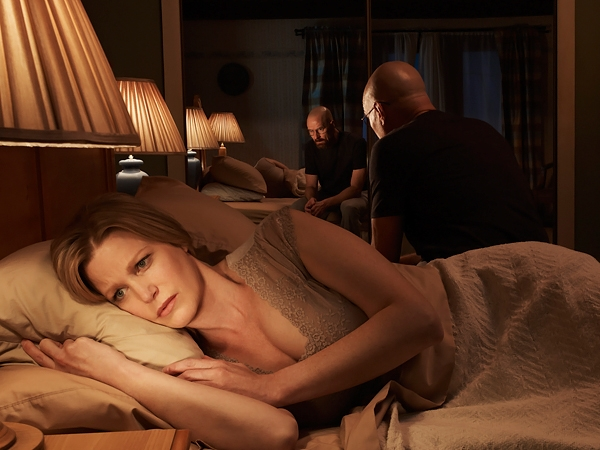What details in the room's decor might suggest something about the characters' personalities or lives? The room is decorated with traditional, somewhat dated furnishings including heavy curtains, intricate lamps, and a sturdy, wood-framed bed. This classic decor could suggest that the characters value privacy and comfort, or possibly hint at conservative values or a desire for stability and order. The presence of personal items like a book and glass on the nightstand add touches of personal life, indicating that despite the current tension, this room is a lived-in, personal space. 